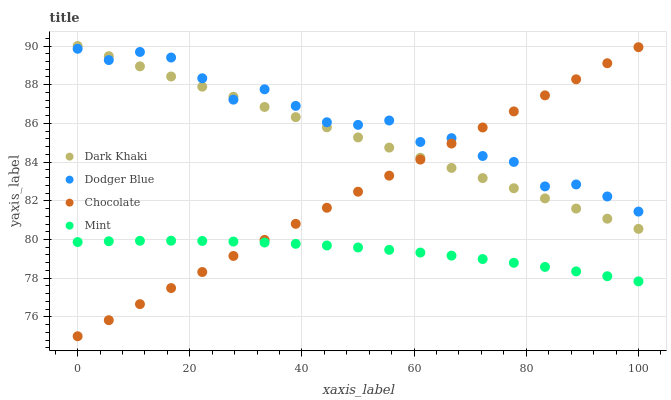Does Mint have the minimum area under the curve?
Answer yes or no. Yes. Does Dodger Blue have the maximum area under the curve?
Answer yes or no. Yes. Does Dodger Blue have the minimum area under the curve?
Answer yes or no. No. Does Mint have the maximum area under the curve?
Answer yes or no. No. Is Chocolate the smoothest?
Answer yes or no. Yes. Is Dodger Blue the roughest?
Answer yes or no. Yes. Is Mint the smoothest?
Answer yes or no. No. Is Mint the roughest?
Answer yes or no. No. Does Chocolate have the lowest value?
Answer yes or no. Yes. Does Mint have the lowest value?
Answer yes or no. No. Does Dark Khaki have the highest value?
Answer yes or no. Yes. Does Dodger Blue have the highest value?
Answer yes or no. No. Is Mint less than Dark Khaki?
Answer yes or no. Yes. Is Dark Khaki greater than Mint?
Answer yes or no. Yes. Does Dark Khaki intersect Dodger Blue?
Answer yes or no. Yes. Is Dark Khaki less than Dodger Blue?
Answer yes or no. No. Is Dark Khaki greater than Dodger Blue?
Answer yes or no. No. Does Mint intersect Dark Khaki?
Answer yes or no. No. 